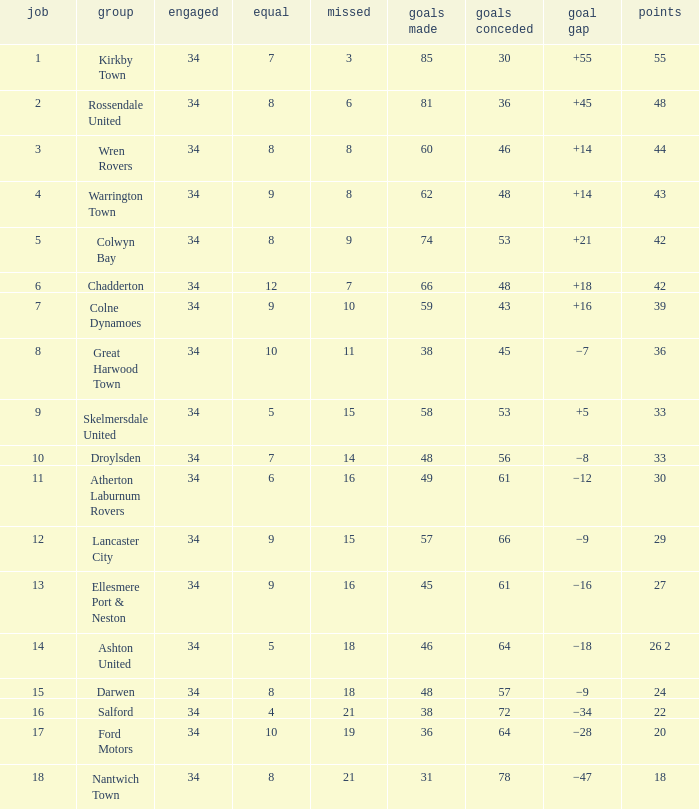What is the smallest number of goals against when there are 1 of 18 points, and more than 8 are drawn? None. 